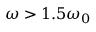<formula> <loc_0><loc_0><loc_500><loc_500>\omega > 1 . 5 \omega _ { 0 }</formula> 